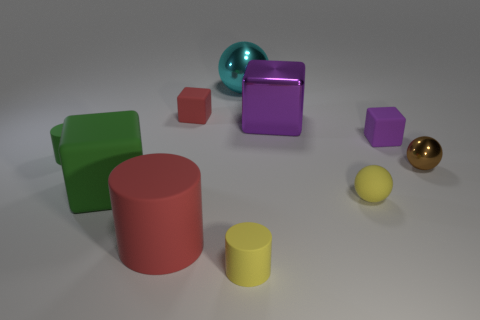Subtract all small cylinders. How many cylinders are left? 1 Subtract all yellow cylinders. How many cylinders are left? 2 Subtract all blocks. How many objects are left? 6 Subtract 1 cylinders. How many cylinders are left? 2 Subtract all yellow spheres. How many purple blocks are left? 2 Add 9 small brown shiny spheres. How many small brown shiny spheres are left? 10 Add 8 yellow cylinders. How many yellow cylinders exist? 9 Subtract 0 blue blocks. How many objects are left? 10 Subtract all blue spheres. Subtract all red cylinders. How many spheres are left? 3 Subtract all big matte cubes. Subtract all large blocks. How many objects are left? 7 